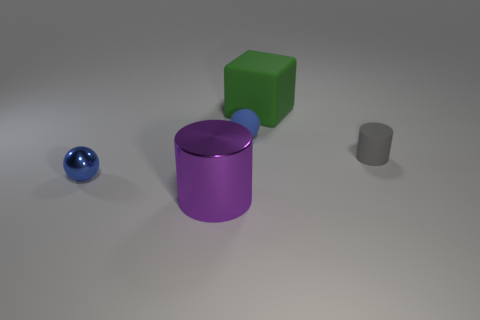How many rubber blocks are the same color as the rubber ball? In the image, there are no rubber blocks that share the same color as the rubber ball. The rubber ball is distinctly blue, and we see one green block, one purple cylinder, and one gray cylinder. Therefore, the answer is 0. 